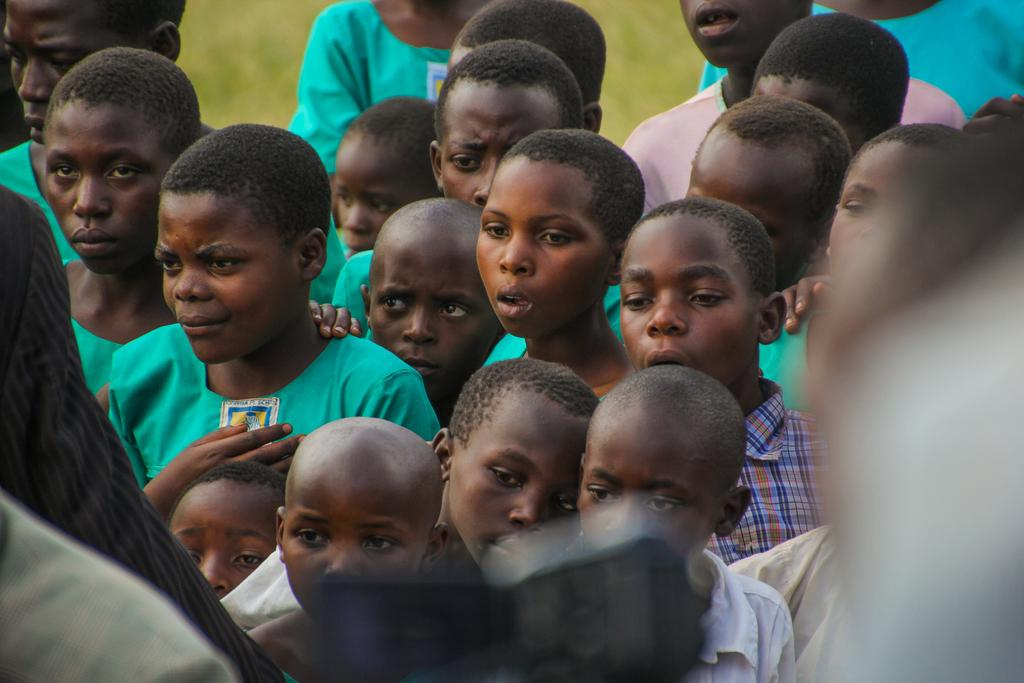How many people are in the image? There is a group of people in the image, but the exact number is not specified. Can you describe the group of people in the image? Unfortunately, the provided facts do not give any details about the group of people. What type of silver object is being used to wash the argument in the image? There is no silver object, argument, or washing activity present in the image. 